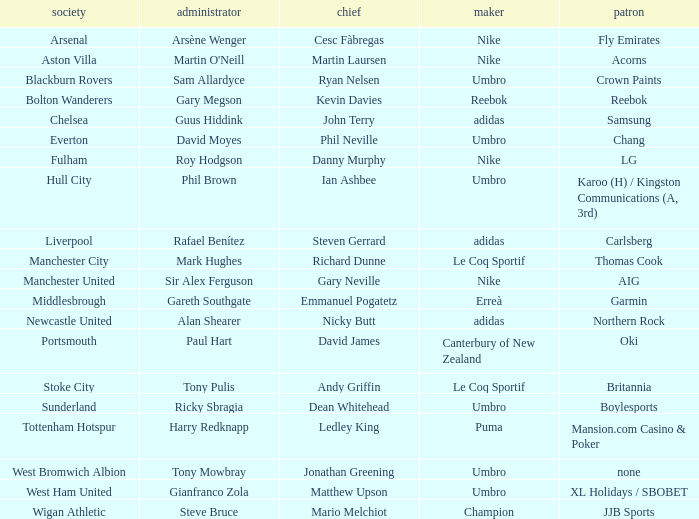Which Manchester United captain is sponsored by Nike? Gary Neville. 